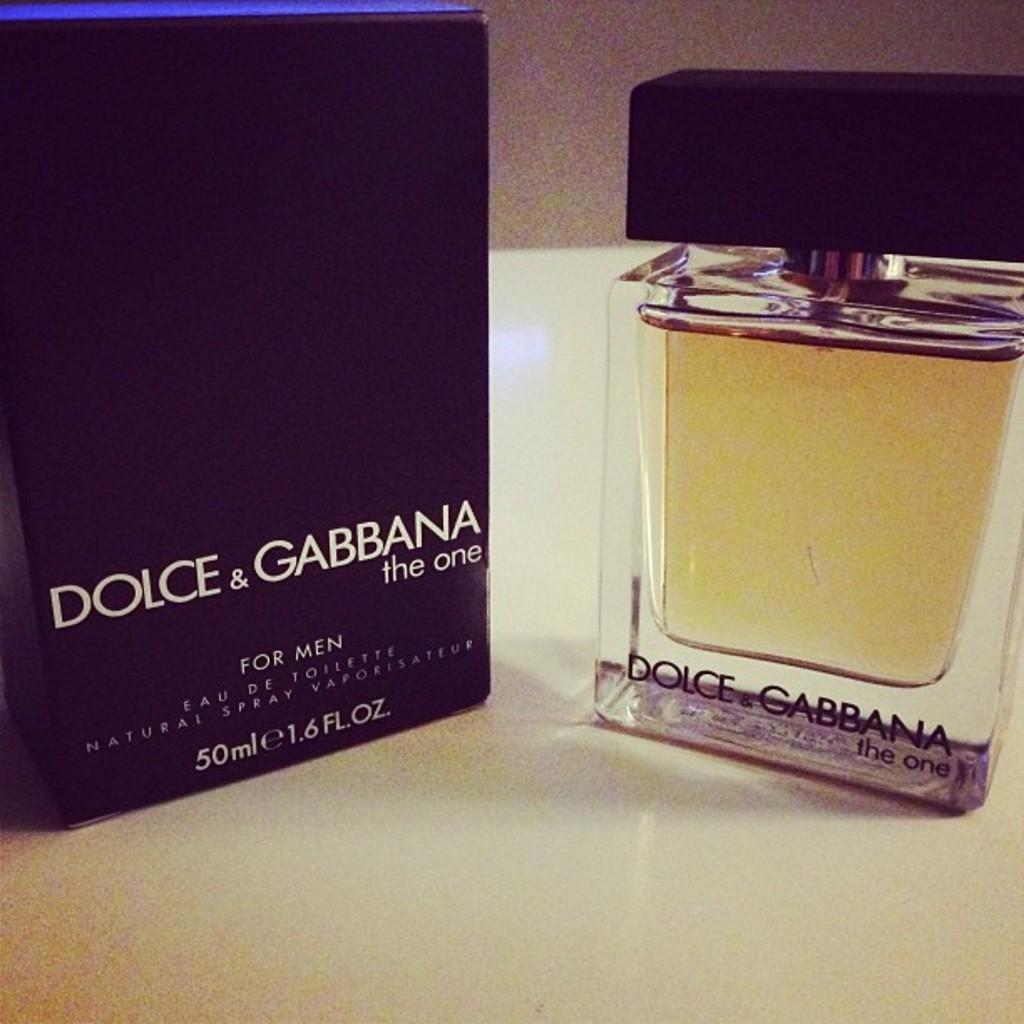What is the brand of this cologne?
Offer a very short reply. Dolce & gabbana. 